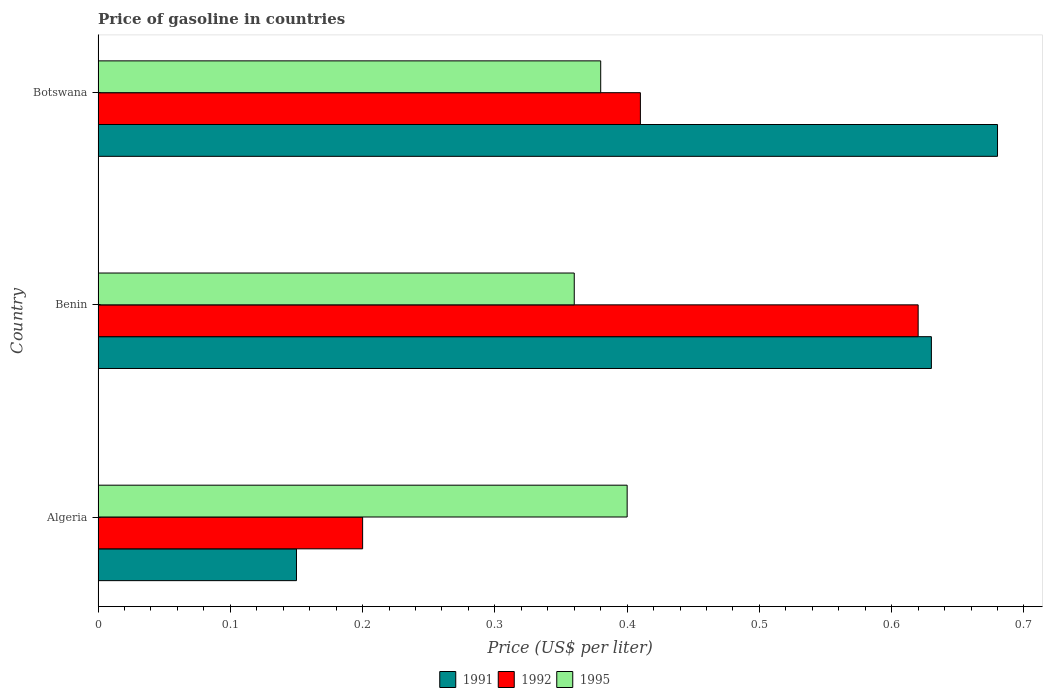How many different coloured bars are there?
Your response must be concise. 3. Are the number of bars per tick equal to the number of legend labels?
Your response must be concise. Yes. Are the number of bars on each tick of the Y-axis equal?
Offer a terse response. Yes. How many bars are there on the 2nd tick from the top?
Your response must be concise. 3. How many bars are there on the 2nd tick from the bottom?
Your answer should be very brief. 3. What is the label of the 2nd group of bars from the top?
Offer a very short reply. Benin. What is the price of gasoline in 1991 in Benin?
Make the answer very short. 0.63. Across all countries, what is the maximum price of gasoline in 1991?
Make the answer very short. 0.68. In which country was the price of gasoline in 1995 maximum?
Provide a succinct answer. Algeria. In which country was the price of gasoline in 1995 minimum?
Ensure brevity in your answer.  Benin. What is the total price of gasoline in 1992 in the graph?
Give a very brief answer. 1.23. What is the difference between the price of gasoline in 1995 in Algeria and that in Benin?
Your answer should be compact. 0.04. What is the difference between the price of gasoline in 1991 in Benin and the price of gasoline in 1992 in Botswana?
Keep it short and to the point. 0.22. What is the average price of gasoline in 1991 per country?
Offer a terse response. 0.49. What is the difference between the price of gasoline in 1992 and price of gasoline in 1991 in Botswana?
Make the answer very short. -0.27. In how many countries, is the price of gasoline in 1991 greater than 0.08 US$?
Offer a terse response. 3. What is the ratio of the price of gasoline in 1995 in Benin to that in Botswana?
Your answer should be very brief. 0.95. Is the price of gasoline in 1992 in Algeria less than that in Botswana?
Make the answer very short. Yes. What is the difference between the highest and the second highest price of gasoline in 1991?
Keep it short and to the point. 0.05. What is the difference between the highest and the lowest price of gasoline in 1992?
Provide a short and direct response. 0.42. What does the 1st bar from the top in Botswana represents?
Your answer should be compact. 1995. How many bars are there?
Your answer should be compact. 9. Are all the bars in the graph horizontal?
Provide a succinct answer. Yes. How many countries are there in the graph?
Offer a very short reply. 3. Are the values on the major ticks of X-axis written in scientific E-notation?
Offer a very short reply. No. Does the graph contain grids?
Your response must be concise. No. What is the title of the graph?
Offer a terse response. Price of gasoline in countries. What is the label or title of the X-axis?
Make the answer very short. Price (US$ per liter). What is the Price (US$ per liter) of 1991 in Algeria?
Ensure brevity in your answer.  0.15. What is the Price (US$ per liter) in 1991 in Benin?
Keep it short and to the point. 0.63. What is the Price (US$ per liter) of 1992 in Benin?
Your response must be concise. 0.62. What is the Price (US$ per liter) of 1995 in Benin?
Your answer should be very brief. 0.36. What is the Price (US$ per liter) in 1991 in Botswana?
Ensure brevity in your answer.  0.68. What is the Price (US$ per liter) of 1992 in Botswana?
Your answer should be very brief. 0.41. What is the Price (US$ per liter) of 1995 in Botswana?
Give a very brief answer. 0.38. Across all countries, what is the maximum Price (US$ per liter) of 1991?
Make the answer very short. 0.68. Across all countries, what is the maximum Price (US$ per liter) of 1992?
Ensure brevity in your answer.  0.62. Across all countries, what is the maximum Price (US$ per liter) in 1995?
Make the answer very short. 0.4. Across all countries, what is the minimum Price (US$ per liter) in 1995?
Your answer should be compact. 0.36. What is the total Price (US$ per liter) of 1991 in the graph?
Provide a succinct answer. 1.46. What is the total Price (US$ per liter) of 1992 in the graph?
Your answer should be compact. 1.23. What is the total Price (US$ per liter) of 1995 in the graph?
Provide a short and direct response. 1.14. What is the difference between the Price (US$ per liter) of 1991 in Algeria and that in Benin?
Your response must be concise. -0.48. What is the difference between the Price (US$ per liter) of 1992 in Algeria and that in Benin?
Provide a succinct answer. -0.42. What is the difference between the Price (US$ per liter) in 1995 in Algeria and that in Benin?
Keep it short and to the point. 0.04. What is the difference between the Price (US$ per liter) in 1991 in Algeria and that in Botswana?
Your answer should be compact. -0.53. What is the difference between the Price (US$ per liter) in 1992 in Algeria and that in Botswana?
Give a very brief answer. -0.21. What is the difference between the Price (US$ per liter) in 1991 in Benin and that in Botswana?
Your answer should be very brief. -0.05. What is the difference between the Price (US$ per liter) of 1992 in Benin and that in Botswana?
Offer a terse response. 0.21. What is the difference between the Price (US$ per liter) of 1995 in Benin and that in Botswana?
Keep it short and to the point. -0.02. What is the difference between the Price (US$ per liter) in 1991 in Algeria and the Price (US$ per liter) in 1992 in Benin?
Your response must be concise. -0.47. What is the difference between the Price (US$ per liter) in 1991 in Algeria and the Price (US$ per liter) in 1995 in Benin?
Provide a succinct answer. -0.21. What is the difference between the Price (US$ per liter) in 1992 in Algeria and the Price (US$ per liter) in 1995 in Benin?
Your response must be concise. -0.16. What is the difference between the Price (US$ per liter) in 1991 in Algeria and the Price (US$ per liter) in 1992 in Botswana?
Keep it short and to the point. -0.26. What is the difference between the Price (US$ per liter) of 1991 in Algeria and the Price (US$ per liter) of 1995 in Botswana?
Your answer should be compact. -0.23. What is the difference between the Price (US$ per liter) in 1992 in Algeria and the Price (US$ per liter) in 1995 in Botswana?
Make the answer very short. -0.18. What is the difference between the Price (US$ per liter) of 1991 in Benin and the Price (US$ per liter) of 1992 in Botswana?
Offer a terse response. 0.22. What is the difference between the Price (US$ per liter) in 1991 in Benin and the Price (US$ per liter) in 1995 in Botswana?
Provide a succinct answer. 0.25. What is the difference between the Price (US$ per liter) in 1992 in Benin and the Price (US$ per liter) in 1995 in Botswana?
Keep it short and to the point. 0.24. What is the average Price (US$ per liter) in 1991 per country?
Provide a succinct answer. 0.49. What is the average Price (US$ per liter) in 1992 per country?
Keep it short and to the point. 0.41. What is the average Price (US$ per liter) in 1995 per country?
Provide a succinct answer. 0.38. What is the difference between the Price (US$ per liter) in 1991 and Price (US$ per liter) in 1992 in Algeria?
Provide a short and direct response. -0.05. What is the difference between the Price (US$ per liter) of 1991 and Price (US$ per liter) of 1992 in Benin?
Your answer should be compact. 0.01. What is the difference between the Price (US$ per liter) of 1991 and Price (US$ per liter) of 1995 in Benin?
Provide a succinct answer. 0.27. What is the difference between the Price (US$ per liter) in 1992 and Price (US$ per liter) in 1995 in Benin?
Your response must be concise. 0.26. What is the difference between the Price (US$ per liter) in 1991 and Price (US$ per liter) in 1992 in Botswana?
Your answer should be compact. 0.27. What is the difference between the Price (US$ per liter) of 1992 and Price (US$ per liter) of 1995 in Botswana?
Ensure brevity in your answer.  0.03. What is the ratio of the Price (US$ per liter) in 1991 in Algeria to that in Benin?
Your answer should be very brief. 0.24. What is the ratio of the Price (US$ per liter) of 1992 in Algeria to that in Benin?
Offer a very short reply. 0.32. What is the ratio of the Price (US$ per liter) of 1995 in Algeria to that in Benin?
Your answer should be compact. 1.11. What is the ratio of the Price (US$ per liter) in 1991 in Algeria to that in Botswana?
Provide a succinct answer. 0.22. What is the ratio of the Price (US$ per liter) of 1992 in Algeria to that in Botswana?
Provide a short and direct response. 0.49. What is the ratio of the Price (US$ per liter) of 1995 in Algeria to that in Botswana?
Your response must be concise. 1.05. What is the ratio of the Price (US$ per liter) in 1991 in Benin to that in Botswana?
Give a very brief answer. 0.93. What is the ratio of the Price (US$ per liter) of 1992 in Benin to that in Botswana?
Your response must be concise. 1.51. What is the ratio of the Price (US$ per liter) of 1995 in Benin to that in Botswana?
Give a very brief answer. 0.95. What is the difference between the highest and the second highest Price (US$ per liter) in 1991?
Offer a very short reply. 0.05. What is the difference between the highest and the second highest Price (US$ per liter) in 1992?
Keep it short and to the point. 0.21. What is the difference between the highest and the lowest Price (US$ per liter) in 1991?
Your answer should be compact. 0.53. What is the difference between the highest and the lowest Price (US$ per liter) of 1992?
Give a very brief answer. 0.42. What is the difference between the highest and the lowest Price (US$ per liter) of 1995?
Keep it short and to the point. 0.04. 